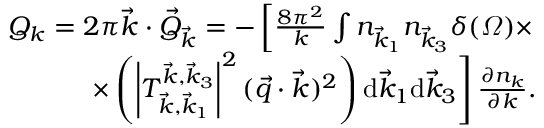<formula> <loc_0><loc_0><loc_500><loc_500>\begin{array} { r } { Q _ { k } = 2 \pi \vec { k } \cdot \vec { Q } _ { \vec { k } } = - \left [ \frac { 8 \pi ^ { 2 } } k \int n _ { \vec { k } _ { 1 } } n _ { \vec { k } _ { 3 } } \delta ( \varOmega ) \times } \\ { \times \left ( \left | T _ { \vec { k } , \vec { k } _ { 1 } } ^ { \vec { k } , \vec { k } _ { 3 } } \right | ^ { 2 } ( \vec { q } \cdot \vec { k } ) ^ { 2 } \right ) \mathrm d \vec { k } _ { 1 } \mathrm d \vec { k } _ { 3 } \right ] \frac { \partial n _ { k } } { \partial k } . } \end{array}</formula> 